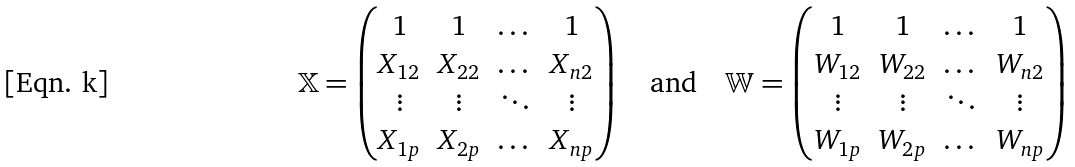Convert formula to latex. <formula><loc_0><loc_0><loc_500><loc_500>\mathbb { X } = \begin{pmatrix} 1 & 1 & \dots & 1 \\ X _ { 1 2 } & X _ { 2 2 } & \dots & X _ { n 2 } \\ \vdots & \vdots & \ddots & \vdots \\ X _ { 1 p } & X _ { 2 p } & \dots & X _ { n p } \end{pmatrix} \quad \text {and} \quad \mathbb { W } = \begin{pmatrix} 1 & 1 & \dots & 1 \\ W _ { 1 2 } & W _ { 2 2 } & \dots & W _ { n 2 } \\ \vdots & \vdots & \ddots & \vdots \\ W _ { 1 p } & W _ { 2 p } & \dots & W _ { n p } \end{pmatrix}</formula> 